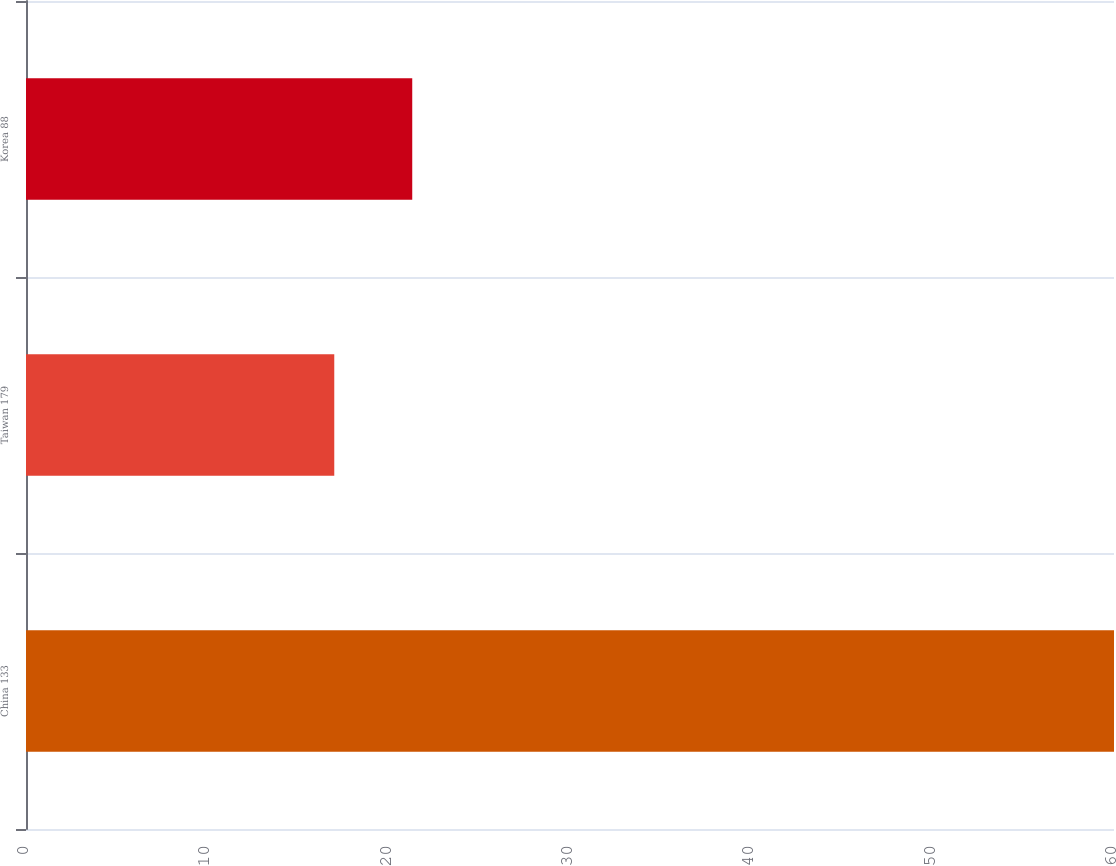Convert chart to OTSL. <chart><loc_0><loc_0><loc_500><loc_500><bar_chart><fcel>China 133<fcel>Taiwan 179<fcel>Korea 88<nl><fcel>60<fcel>17<fcel>21.3<nl></chart> 